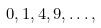Convert formula to latex. <formula><loc_0><loc_0><loc_500><loc_500>0 , 1 , 4 , 9 , \dots ,</formula> 